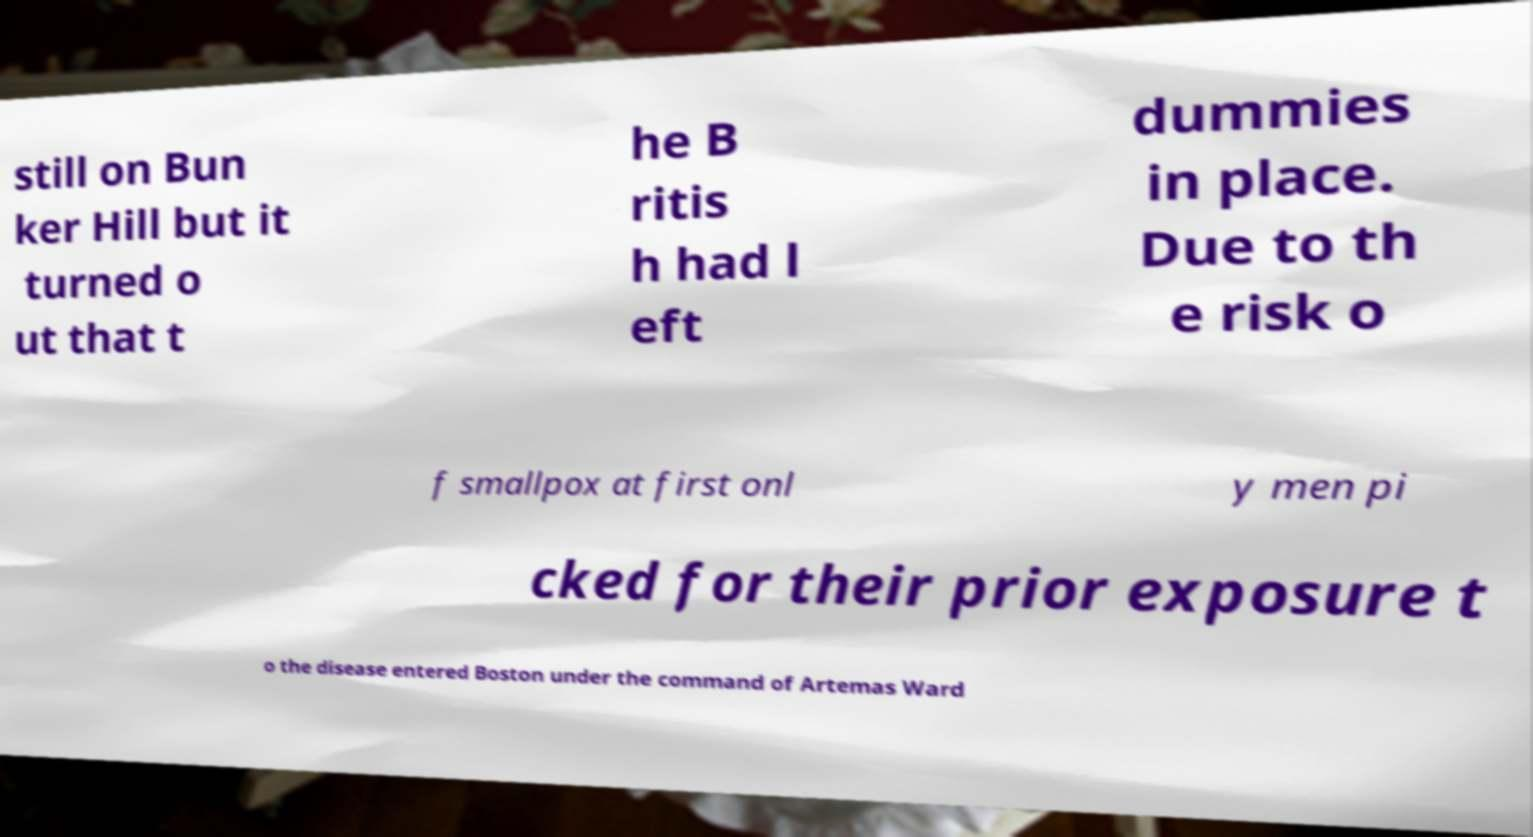Please read and relay the text visible in this image. What does it say? still on Bun ker Hill but it turned o ut that t he B ritis h had l eft dummies in place. Due to th e risk o f smallpox at first onl y men pi cked for their prior exposure t o the disease entered Boston under the command of Artemas Ward 